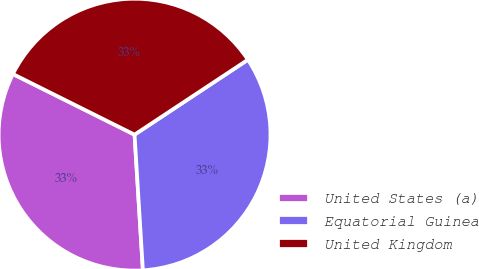Convert chart to OTSL. <chart><loc_0><loc_0><loc_500><loc_500><pie_chart><fcel>United States (a)<fcel>Equatorial Guinea<fcel>United Kingdom<nl><fcel>33.34%<fcel>33.32%<fcel>33.34%<nl></chart> 